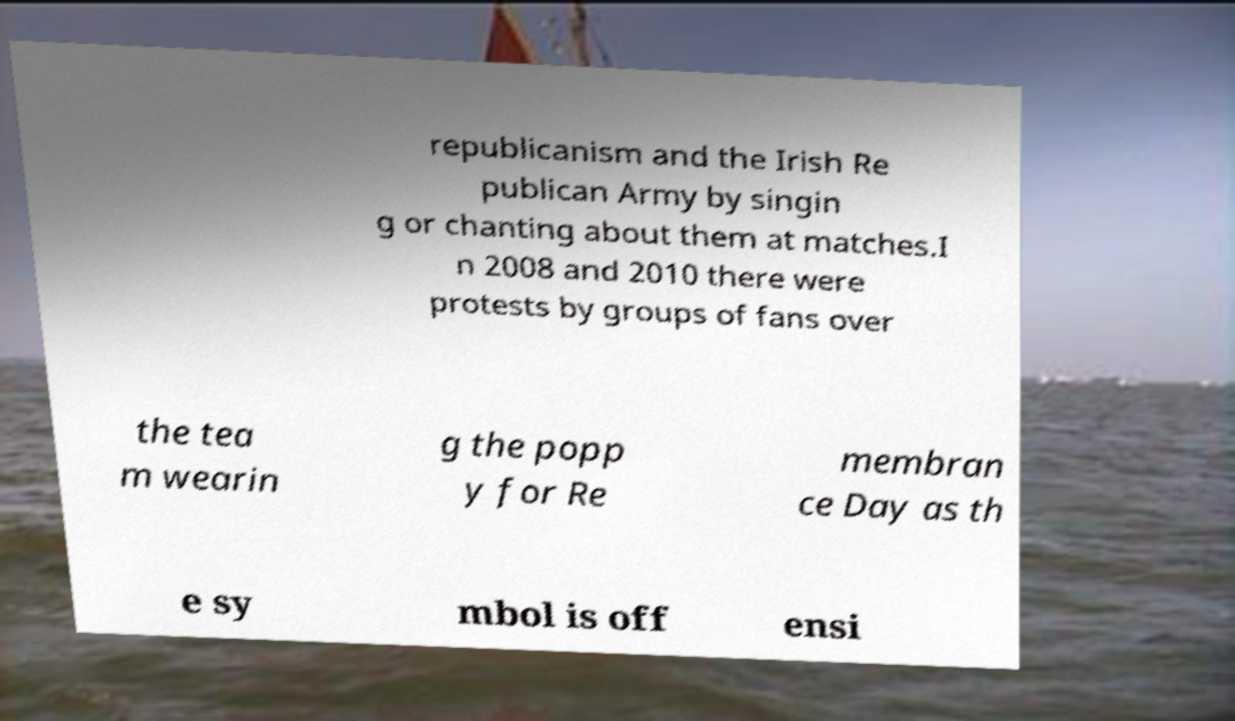I need the written content from this picture converted into text. Can you do that? republicanism and the Irish Re publican Army by singin g or chanting about them at matches.I n 2008 and 2010 there were protests by groups of fans over the tea m wearin g the popp y for Re membran ce Day as th e sy mbol is off ensi 